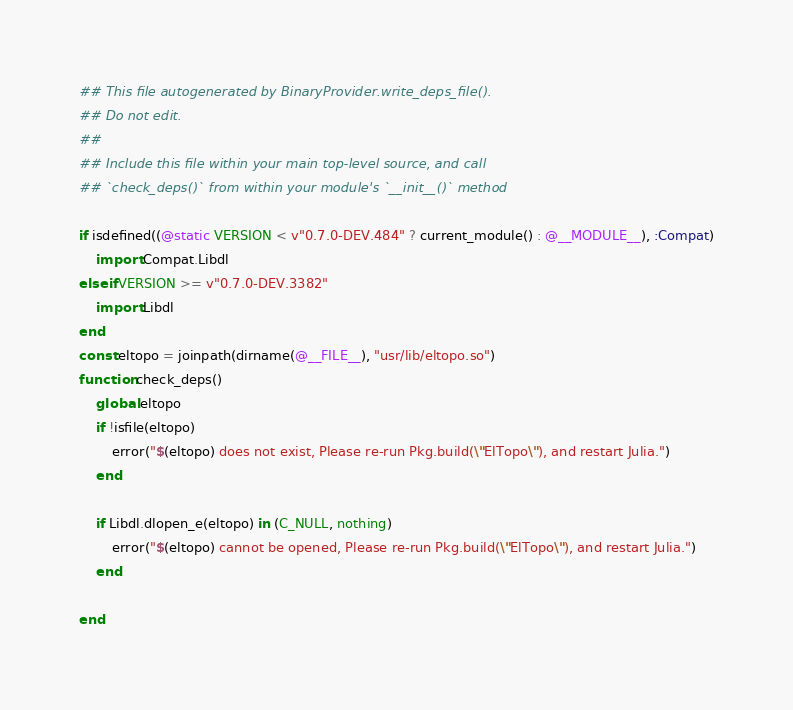<code> <loc_0><loc_0><loc_500><loc_500><_Julia_>## This file autogenerated by BinaryProvider.write_deps_file().
## Do not edit.
##
## Include this file within your main top-level source, and call
## `check_deps()` from within your module's `__init__()` method

if isdefined((@static VERSION < v"0.7.0-DEV.484" ? current_module() : @__MODULE__), :Compat)
    import Compat.Libdl
elseif VERSION >= v"0.7.0-DEV.3382"
    import Libdl
end
const eltopo = joinpath(dirname(@__FILE__), "usr/lib/eltopo.so")
function check_deps()
    global eltopo
    if !isfile(eltopo)
        error("$(eltopo) does not exist, Please re-run Pkg.build(\"ElTopo\"), and restart Julia.")
    end

    if Libdl.dlopen_e(eltopo) in (C_NULL, nothing)
        error("$(eltopo) cannot be opened, Please re-run Pkg.build(\"ElTopo\"), and restart Julia.")
    end

end
</code> 